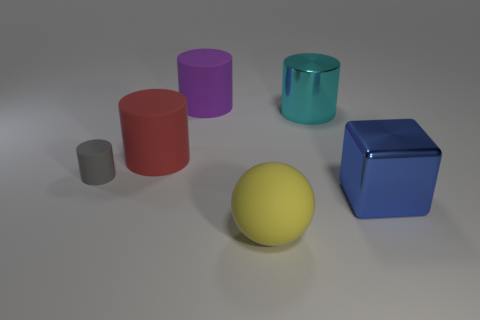There is a metal object behind the big object that is on the right side of the cylinder that is on the right side of the purple object; what shape is it? The object in question, located behind the large red cylinder which is to the right of the purple cylinder, appears to be a blue cube. 